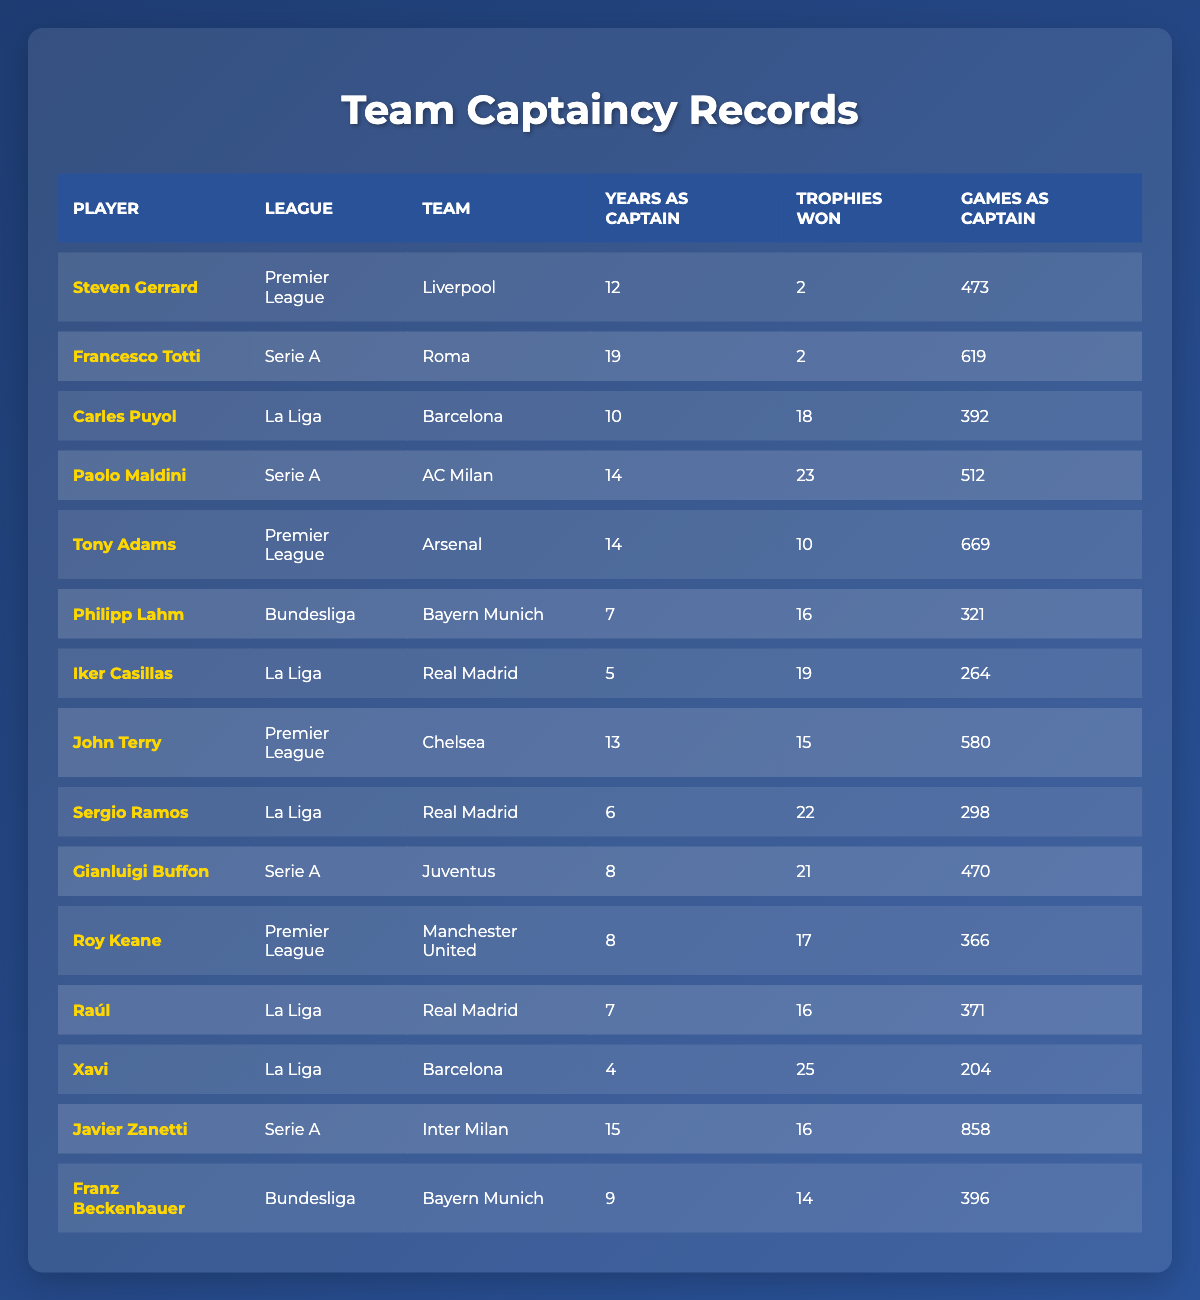What is the total number of trophies won by players in the Premier League? To find the total, we look at the "Trophies Won" column for players in the Premier League: Steven Gerrard (2), Tony Adams (10), and John Terry (15). Adding these values gives us 2 + 10 + 15 = 27.
Answer: 27 Which player has the most games as captain in Serie A? In the Serie A column, we check the "Games as Captain": Francesco Totti (619), Paolo Maldini (512), and Gianluigi Buffon (470). The highest value among these is 619, which belongs to Francesco Totti.
Answer: Francesco Totti Did any player win more than 20 trophies as captain in La Liga? We evaluate the "Trophies Won" column for La Liga: Carles Puyol (18), Iker Casillas (19), Sergio Ramos (22), and Raúl (16). Since Sergio Ramos has 22 trophies, the answer is yes.
Answer: Yes What is the average number of years players served as captain in the Bundesliga? For the Bundesliga, we check the "Years as Captain": Philipp Lahm (7) and Franz Beckenbauer (9). We sum these values: 7 + 9 = 16, then divide by the number of players (2), resulting in an average of 16 / 2 = 8.
Answer: 8 Who was the captain of AC Milan and how many trophies did they win? Looking for the captain of AC Milan in the table, we find Paolo Maldini, who won 23 trophies.
Answer: Paolo Maldini, 23 Which league has the highest total number of games as captain? To determine this, we sum the "Games as Captain" for each league: Premier League (473 + 669 + 580 = 1722), Serie A (619 + 512 + 470 + 858 = 2679), La Liga (392 + 264 + 298 + 371 = 1325), and Bundesliga (321 + 396 = 717). The highest total belongs to Serie A with 2679 games.
Answer: Serie A Can we find a player who captained his team for exactly 10 years and won 10 or fewer trophies? Looking through the table, Tony Adams captained for 14 years and won 10 trophies, while no other player with 10 years as a captain has won 10 or fewer trophies. Therefore, the answer is no player matches this description.
Answer: No What is the total number of games captained by players from Real Madrid? For Real Madrid players, we identify Iker Casillas (264), Sergio Ramos (298), and Raúl (371). Summing these values gives 264 + 298 + 371 = 933.
Answer: 933 